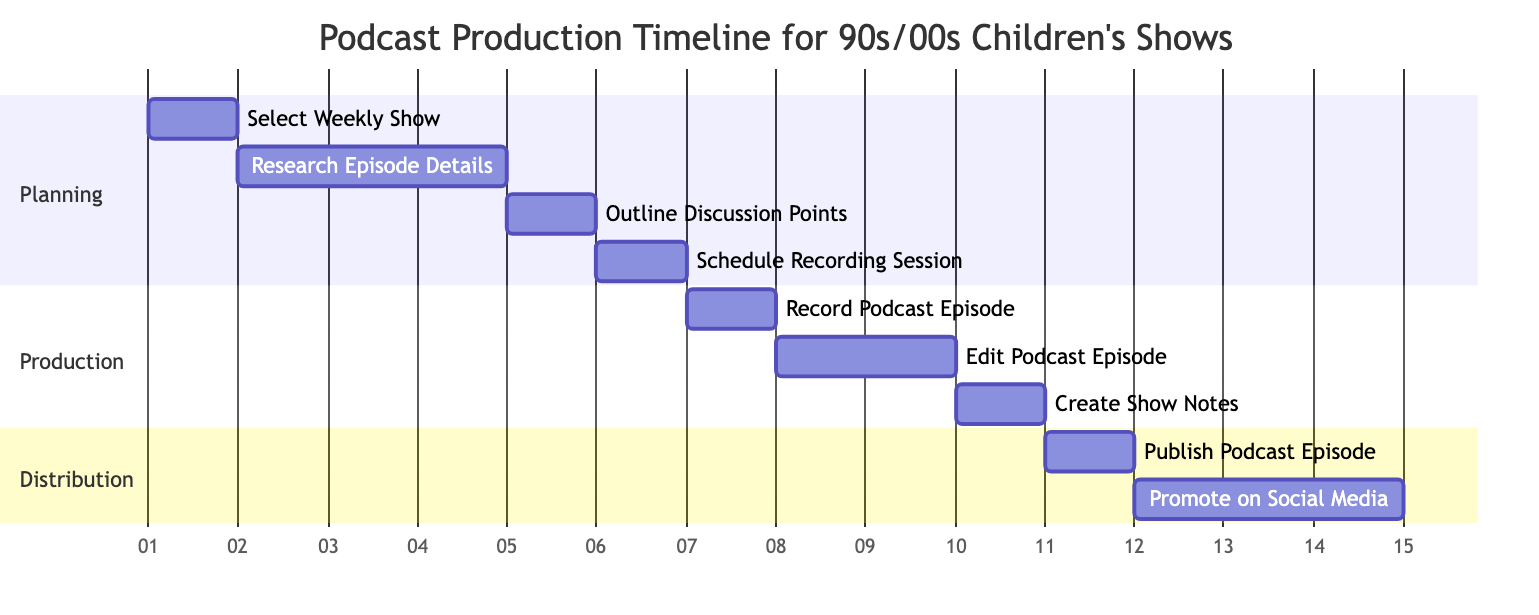What is the duration for the "Research Episode Details" task? The diagram shows that the "Research Episode Details" task is assigned a duration of 3 days. This is clearly indicated next to the task in the diagram.
Answer: 3 days How many days are allocated for the "Edit Podcast Episode"? The “Edit Podcast Episode” task is listed with a duration of 2 days in the diagram. This can be found by checking the duration next to this specific task.
Answer: 2 days What task follows "Outline Discussion Points"? The diagram clearly shows that “Schedule Recording Session” comes directly after "Outline Discussion Points". This is indicated by the order of tasks and the arrows connecting them.
Answer: Schedule Recording Session Which section does "Promote Episode on Social Media" belong to? The “Promote Episode on Social Media” task is categorized under the "Distribution" section in the diagram. This can be identified as it is listed under that specific title.
Answer: Distribution What is the total number of tasks in the Gantt chart? By counting all listed tasks in the diagram, there are a total of 9 tasks included: "Select Weekly Show", "Research Episode Details", "Outline Discussion Points", "Schedule Recording Session", "Record Podcast Episode", "Edit Podcast Episode", "Create Show Notes", "Publish Podcast Episode", and "Promote Episode on Social Media".
Answer: 9 Which task has the longest total timeline? To find the task with the longest total timeline, we look at the durations of each task, particularly those that are sequential. The longest in terms of total planned time is the "Promote Episode on Social Media" task, spanning 3 days after the previous tasks are completed.
Answer: Promote Episode on Social Media How many tasks are in the "Production" section? In the diagram, the "Production" section contains 3 tasks: "Record Podcast Episode", "Edit Podcast Episode", and "Create Show Notes". These tasks can be counted directly from the section titled "Production".
Answer: 3 tasks What task precedes "Publish Podcast Episode"? The diagram indicates that "Create Show Notes" is the task that comes directly before the "Publish Podcast Episode" task, making it the preceding task.
Answer: Create Show Notes 